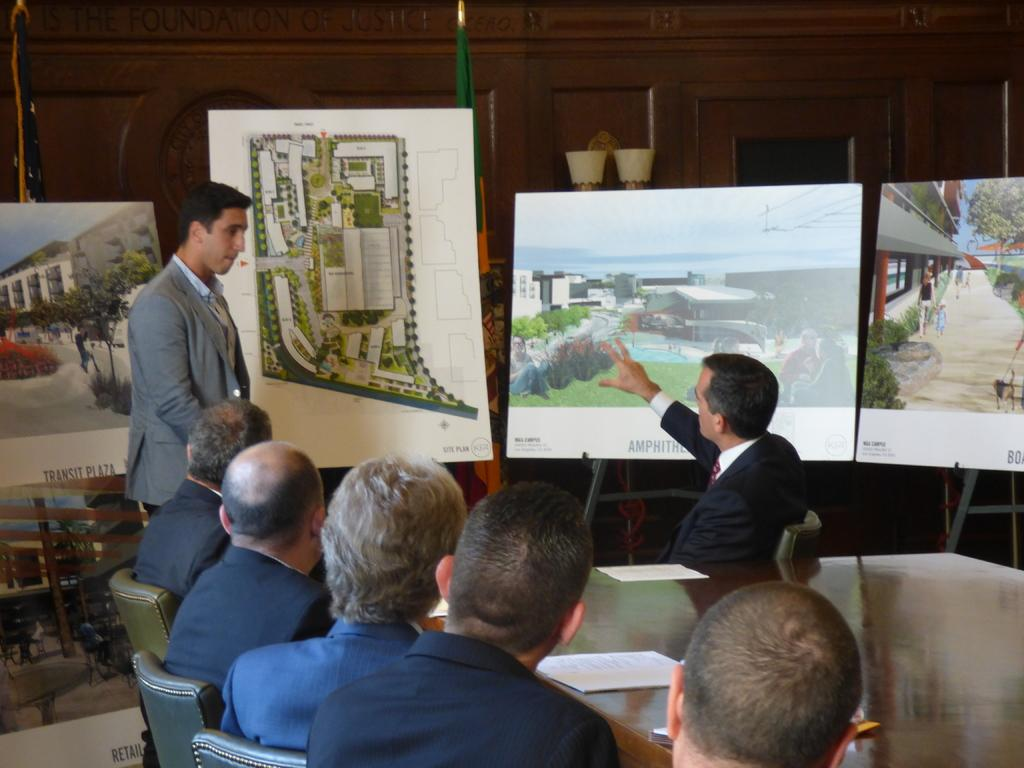What are the people in the image doing? The group of people is sitting on chairs in front of a table. Can you describe the position of the man in the image? A man is standing on the floor. What objects are present on the table? There are paint boards on the table. What type of skate is the man using to move around in the image? There is no skate present in the image; the man is standing on the floor. Can you describe the snake that is slithering across the table in the image? There is no snake present in the image; the table only has paint boards on it. 